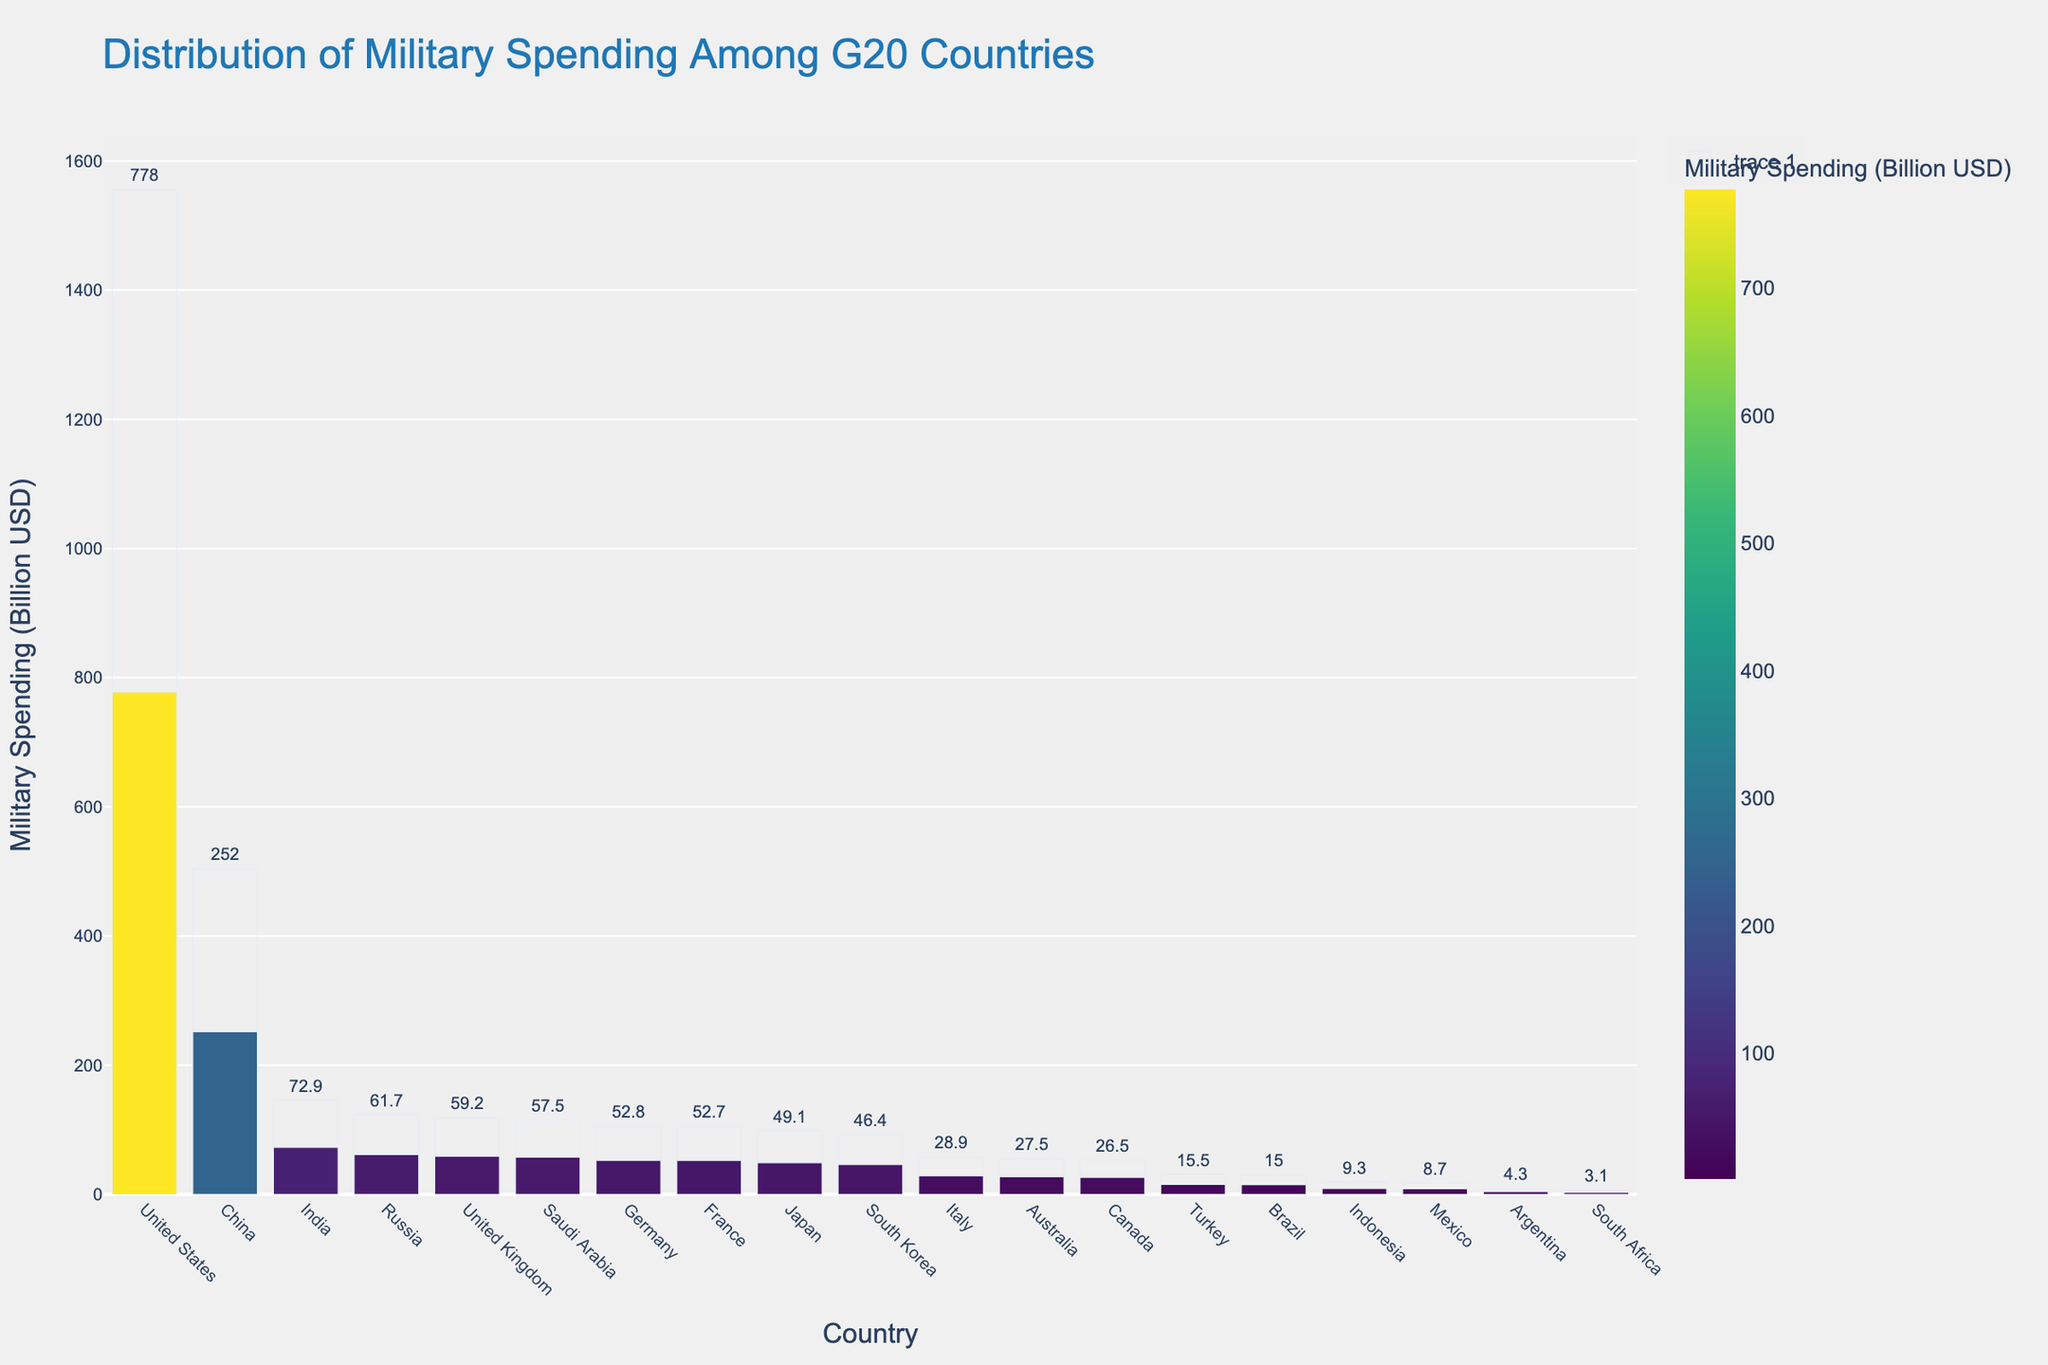What country has the highest military spending? From the bar chart, the United States has the tallest bar, indicating the highest military spending among the G20 countries.
Answer: United States How much more does China spend on military than India? The visual representation shows China's military spending at 252.0 billion USD and India's at 72.9 billion USD. Subtract India's spending from China's: 252.0 - 72.9 = 179.1 billion USD.
Answer: 179.1 billion USD Which countries have military spending above 50 billion USD? By examining the height of the bars, the countries with spending above 50 billion USD are the United States (778.0), China (252.0), India (72.9), Russia (61.7), United Kingdom (59.2), Saudi Arabia (57.5), Germany (52.8), and France (52.7).
Answer: United States, China, India, Russia, United Kingdom, Saudi Arabia, Germany, France What is the total military spending of the top 3 spenders? Adding the spending values of the top three countries: United States (778.0) + China (252.0) + India (72.9) results in 1102.9 billion USD.
Answer: 1102.9 billion USD How does South Korea's military spending compare to Japan's? From the figure, South Korea's military spending is 46.4 billion USD and Japan's is 49.1 billion USD. Japan spends slightly more on the military than South Korea.
Answer: Japan spends more What is the average military spending of the countries with the five lowest spending in the G20? Identify the countries with the lowest spending: South Africa (3.1), Argentina (4.3), Mexico (8.7), Indonesia (9.3), and Brazil (15.0). Computing the average: (3.1 + 4.3 + 8.7 + 9.3 + 15.0) / 5 = 8.08 billion USD.
Answer: 8.08 billion USD Which color represents the highest military spending, and what does it signify? The tallest bar, which belongs to the United States, is shaded in the darkest color on the Viridis scale.
Answer: Darkest color (Viridis scale) By how much does the combined military spending of Saudi Arabia and the United Kingdom exceed that of Germany? Add Saudi Arabia's (57.5) and the United Kingdom's (59.2) spending to get 116.7 billion USD together. Germany's spending is 52.8 billion USD. Difference: 116.7 - 52.8 = 63.9 billion USD.
Answer: 63.9 billion USD How much more does the United States spend on military than the last five countries combined? Calculate the total spending of the last five: South Africa (3.1), Argentina (4.3), Mexico (8.7), Indonesia (9.3), Brazil (15.0) which sums to 40.4 billion USD. The United States spends 778.0 billion USD. Difference: 778.0 - 40.4 = 737.6 billion USD.
Answer: 737.6 billion USD 